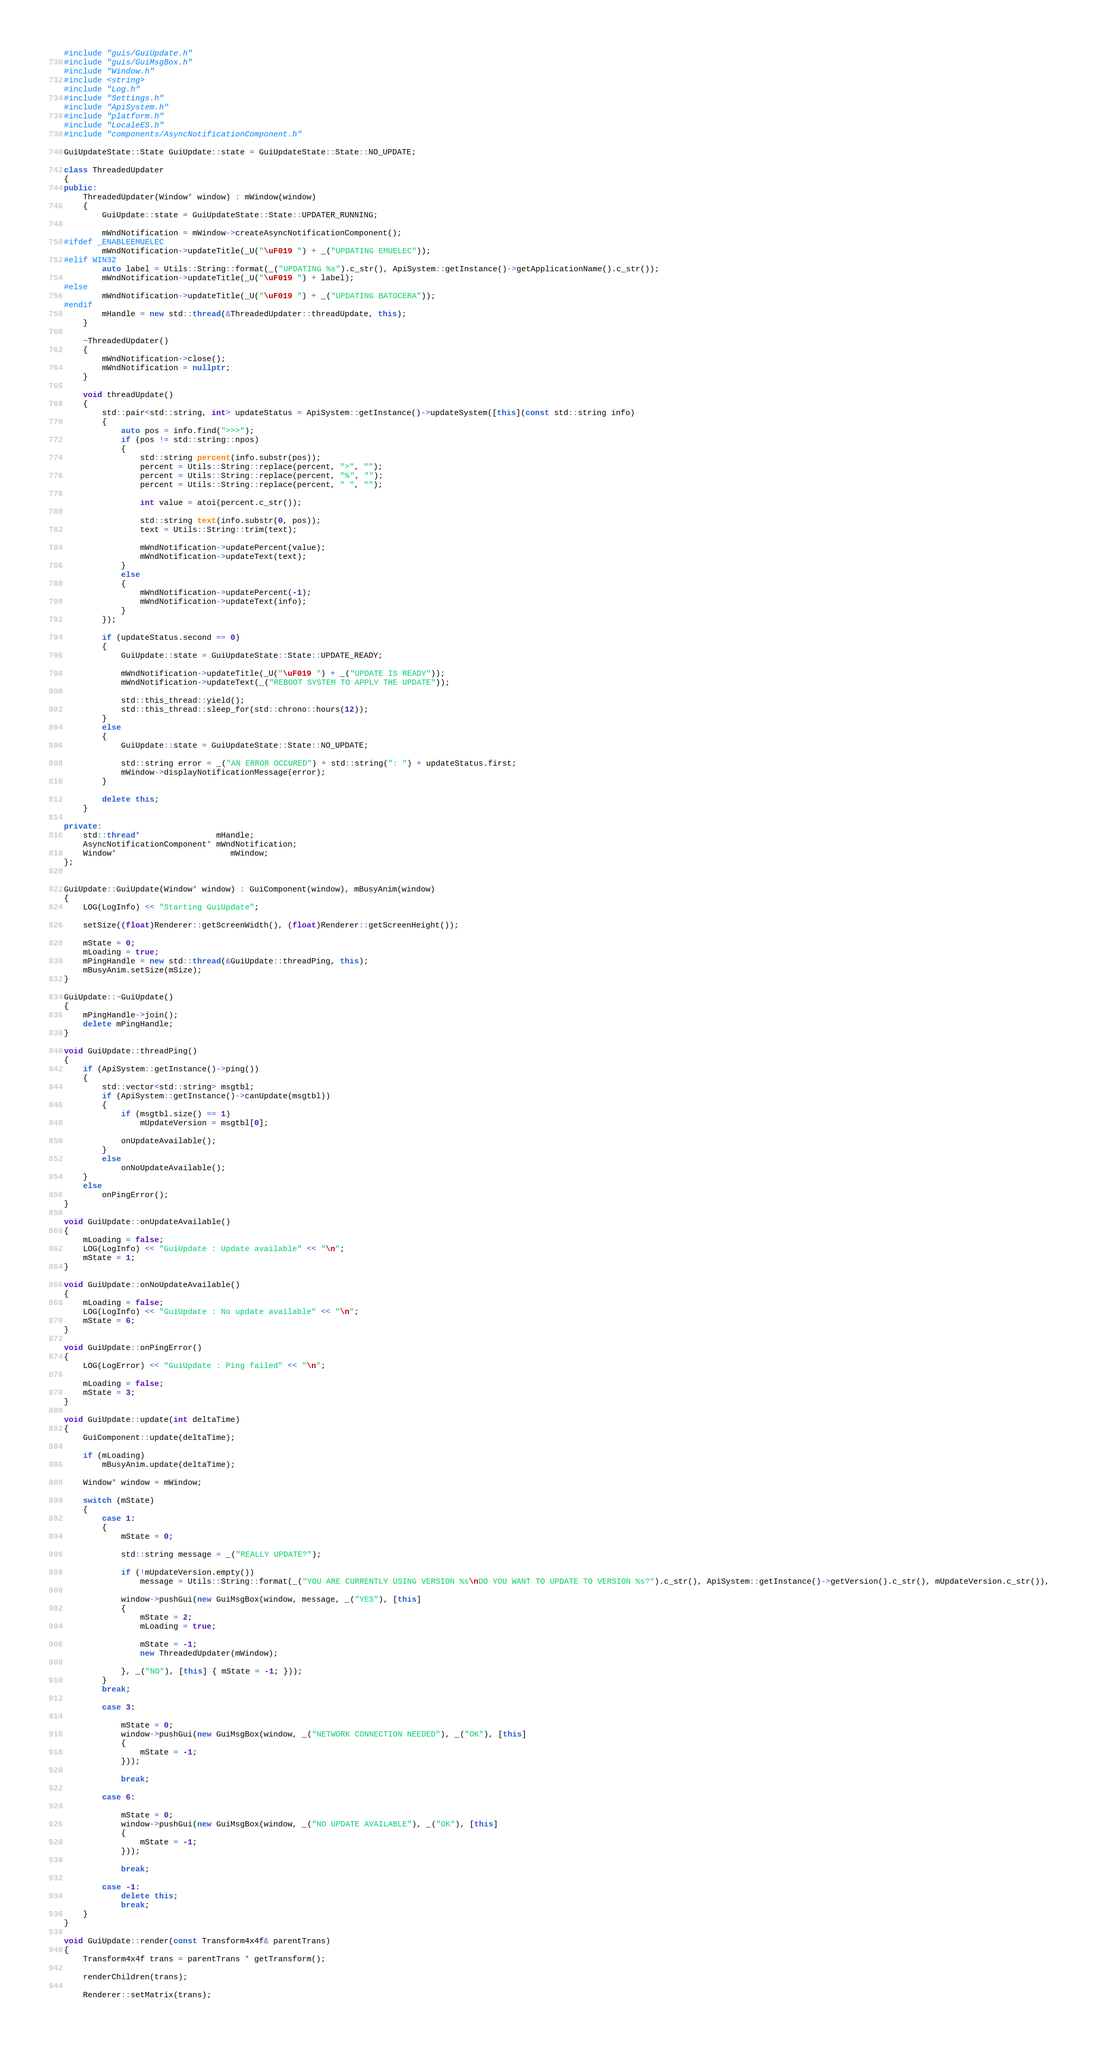Convert code to text. <code><loc_0><loc_0><loc_500><loc_500><_C++_>#include "guis/GuiUpdate.h"
#include "guis/GuiMsgBox.h"
#include "Window.h"
#include <string>
#include "Log.h"
#include "Settings.h"
#include "ApiSystem.h"
#include "platform.h"
#include "LocaleES.h"
#include "components/AsyncNotificationComponent.h"

GuiUpdateState::State GuiUpdate::state = GuiUpdateState::State::NO_UPDATE;

class ThreadedUpdater
{
public:
	ThreadedUpdater(Window* window) : mWindow(window)
	{
		GuiUpdate::state = GuiUpdateState::State::UPDATER_RUNNING;

		mWndNotification = mWindow->createAsyncNotificationComponent();
#ifdef _ENABLEEMUELEC
		mWndNotification->updateTitle(_U("\uF019 ") + _("UPDATING EMUELEC"));
#elif WIN32
		auto label = Utils::String::format(_("UPDATING %s").c_str(), ApiSystem::getInstance()->getApplicationName().c_str());
		mWndNotification->updateTitle(_U("\uF019 ") + label);
#else
		mWndNotification->updateTitle(_U("\uF019 ") + _("UPDATING BATOCERA"));
#endif
		mHandle = new std::thread(&ThreadedUpdater::threadUpdate, this);
	}

	~ThreadedUpdater()
	{
		mWndNotification->close();
		mWndNotification = nullptr;
	}

	void threadUpdate()
	{
		std::pair<std::string, int> updateStatus = ApiSystem::getInstance()->updateSystem([this](const std::string info)
		{
			auto pos = info.find(">>>");
			if (pos != std::string::npos)
			{
				std::string percent(info.substr(pos));		
				percent = Utils::String::replace(percent, ">", "");
				percent = Utils::String::replace(percent, "%", "");
				percent = Utils::String::replace(percent, " ", "");

				int value = atoi(percent.c_str());

				std::string text(info.substr(0, pos));
				text = Utils::String::trim(text);

				mWndNotification->updatePercent(value);
				mWndNotification->updateText(text);
			}
			else
			{
				mWndNotification->updatePercent(-1);
				mWndNotification->updateText(info);
			}
		});

		if (updateStatus.second == 0)
		{
			GuiUpdate::state = GuiUpdateState::State::UPDATE_READY;

			mWndNotification->updateTitle(_U("\uF019 ") + _("UPDATE IS READY"));
			mWndNotification->updateText(_("REBOOT SYSTEM TO APPLY THE UPDATE"));

			std::this_thread::yield();
			std::this_thread::sleep_for(std::chrono::hours(12));
		}
		else
		{
			GuiUpdate::state = GuiUpdateState::State::NO_UPDATE;

			std::string error = _("AN ERROR OCCURED") + std::string(": ") + updateStatus.first;
			mWindow->displayNotificationMessage(error);
		}

		delete this;
	}

private:
	std::thread*				mHandle;
	AsyncNotificationComponent* mWndNotification;
	Window*						mWindow;
};


GuiUpdate::GuiUpdate(Window* window) : GuiComponent(window), mBusyAnim(window)
{
	LOG(LogInfo) << "Starting GuiUpdate";

	setSize((float)Renderer::getScreenWidth(), (float)Renderer::getScreenHeight());

	mState = 0;	
    mLoading = true;
    mPingHandle = new std::thread(&GuiUpdate::threadPing, this);
    mBusyAnim.setSize(mSize);
}

GuiUpdate::~GuiUpdate()
{	
	mPingHandle->join();
	delete mPingHandle;
}

void GuiUpdate::threadPing()
{	
	if (ApiSystem::getInstance()->ping())
	{
		std::vector<std::string> msgtbl;
		if (ApiSystem::getInstance()->canUpdate(msgtbl))
		{
			if (msgtbl.size() == 1)
				mUpdateVersion = msgtbl[0];

			onUpdateAvailable();
		}
		else
			onNoUpdateAvailable();
	}
	else
		onPingError();
}

void GuiUpdate::onUpdateAvailable()
{
	mLoading = false;
	LOG(LogInfo) << "GuiUpdate : Update available" << "\n";
	mState = 1;
}

void GuiUpdate::onNoUpdateAvailable()
{
	mLoading = false;
	LOG(LogInfo) << "GuiUpdate : No update available" << "\n";
	mState = 6;
}

void GuiUpdate::onPingError()
{
	LOG(LogError) << "GuiUpdate : Ping failed" << "\n";

	mLoading = false;
	mState = 3;
}

void GuiUpdate::update(int deltaTime)
{
	GuiComponent::update(deltaTime);

	if (mLoading)
		mBusyAnim.update(deltaTime);

	Window* window = mWindow;

	switch (mState)
	{
		case 1:
		{
			mState = 0;

			std::string message = _("REALLY UPDATE?");

			if (!mUpdateVersion.empty())
				message = Utils::String::format(_("YOU ARE CURRENTLY USING VERSION %s\nDO YOU WANT TO UPDATE TO VERSION %s?").c_str(), ApiSystem::getInstance()->getVersion().c_str(), mUpdateVersion.c_str()),

			window->pushGui(new GuiMsgBox(window, message, _("YES"), [this]
			{
				mState = 2;
				mLoading = true;

				mState = -1;
				new ThreadedUpdater(mWindow);

			}, _("NO"), [this] { mState = -1; }));
		}		
		break;

		case 3:
		
			mState = 0;
			window->pushGui(new GuiMsgBox(window, _("NETWORK CONNECTION NEEDED"), _("OK"), [this] 
			{
				mState = -1;
			}));			
		
			break;

		case 6:

			mState = 0;
			window->pushGui(new GuiMsgBox(window, _("NO UPDATE AVAILABLE"), _("OK"), [this] 
			{
				mState = -1;
			}));

			break;

		case -1:
			delete this;
			break;
	}
}

void GuiUpdate::render(const Transform4x4f& parentTrans)
{
	Transform4x4f trans = parentTrans * getTransform();

	renderChildren(trans);

	Renderer::setMatrix(trans);</code> 